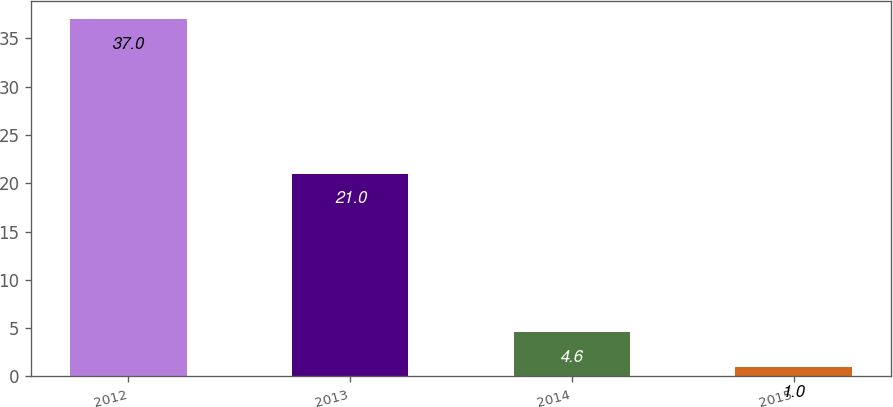Convert chart to OTSL. <chart><loc_0><loc_0><loc_500><loc_500><bar_chart><fcel>2012<fcel>2013<fcel>2014<fcel>2015<nl><fcel>37<fcel>21<fcel>4.6<fcel>1<nl></chart> 